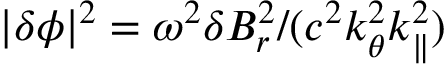Convert formula to latex. <formula><loc_0><loc_0><loc_500><loc_500>| \delta \phi | ^ { 2 } = \omega ^ { 2 } \delta B _ { r } ^ { 2 } / ( c ^ { 2 } k _ { \theta } ^ { 2 } k _ { \| } ^ { 2 } )</formula> 